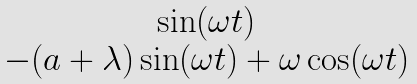Convert formula to latex. <formula><loc_0><loc_0><loc_500><loc_500>\begin{matrix} \sin ( \omega t ) \\ - ( a + \lambda ) \sin ( \omega t ) + \omega \cos ( \omega t ) \end{matrix}</formula> 